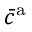<formula> <loc_0><loc_0><loc_500><loc_500>\bar { c } ^ { a }</formula> 